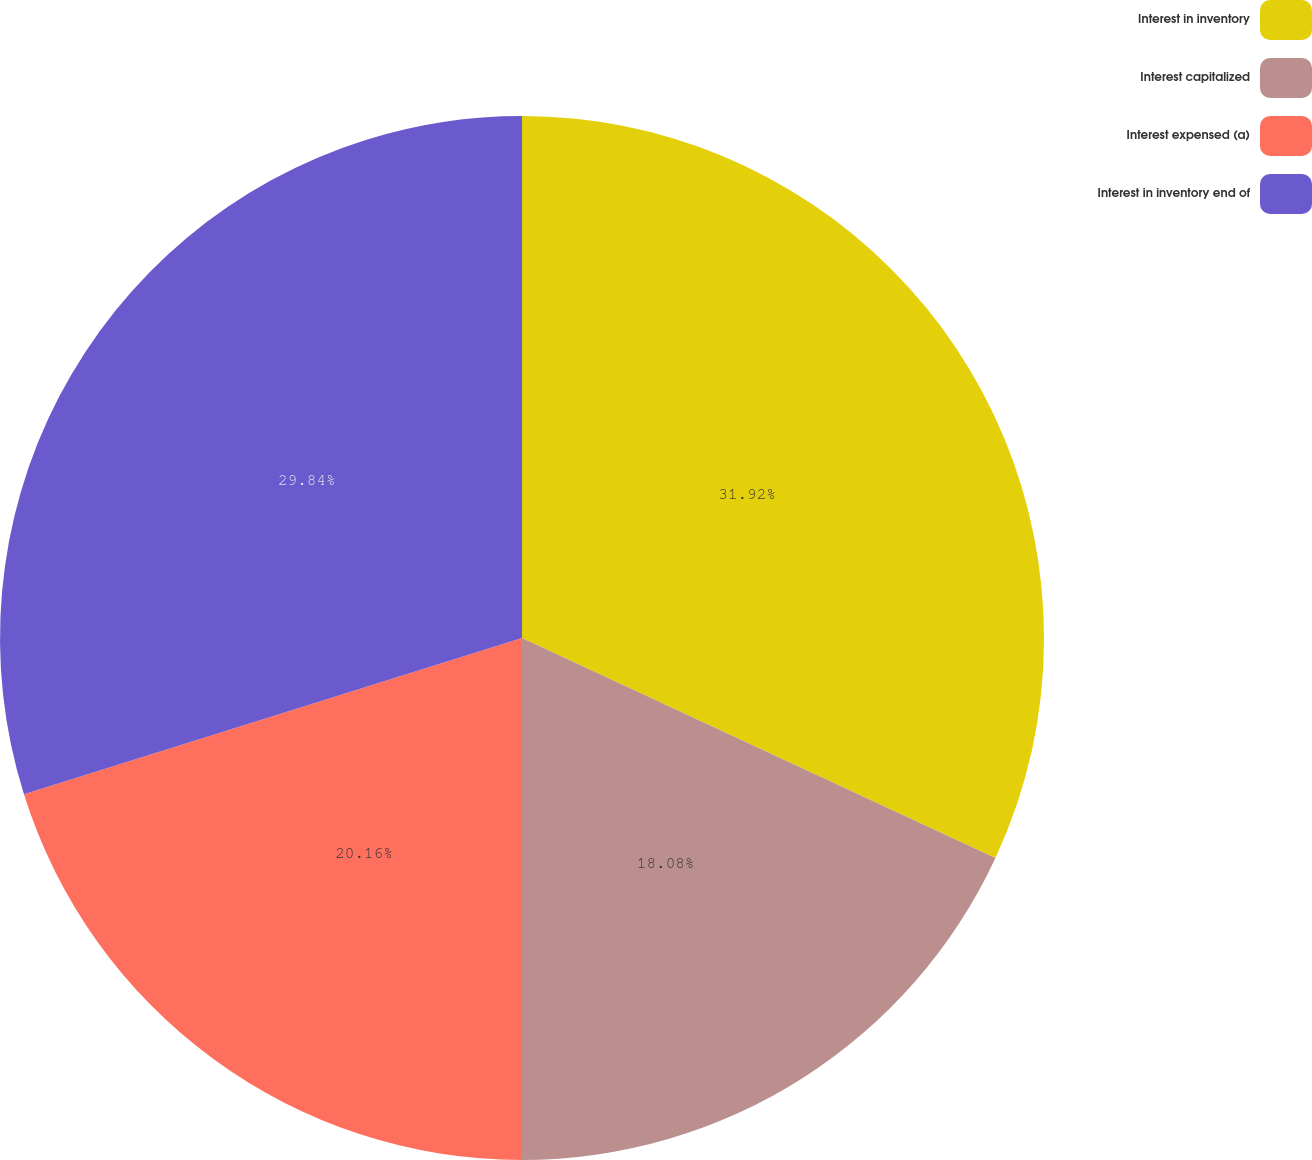<chart> <loc_0><loc_0><loc_500><loc_500><pie_chart><fcel>Interest in inventory<fcel>Interest capitalized<fcel>Interest expensed (a)<fcel>Interest in inventory end of<nl><fcel>31.92%<fcel>18.08%<fcel>20.16%<fcel>29.84%<nl></chart> 